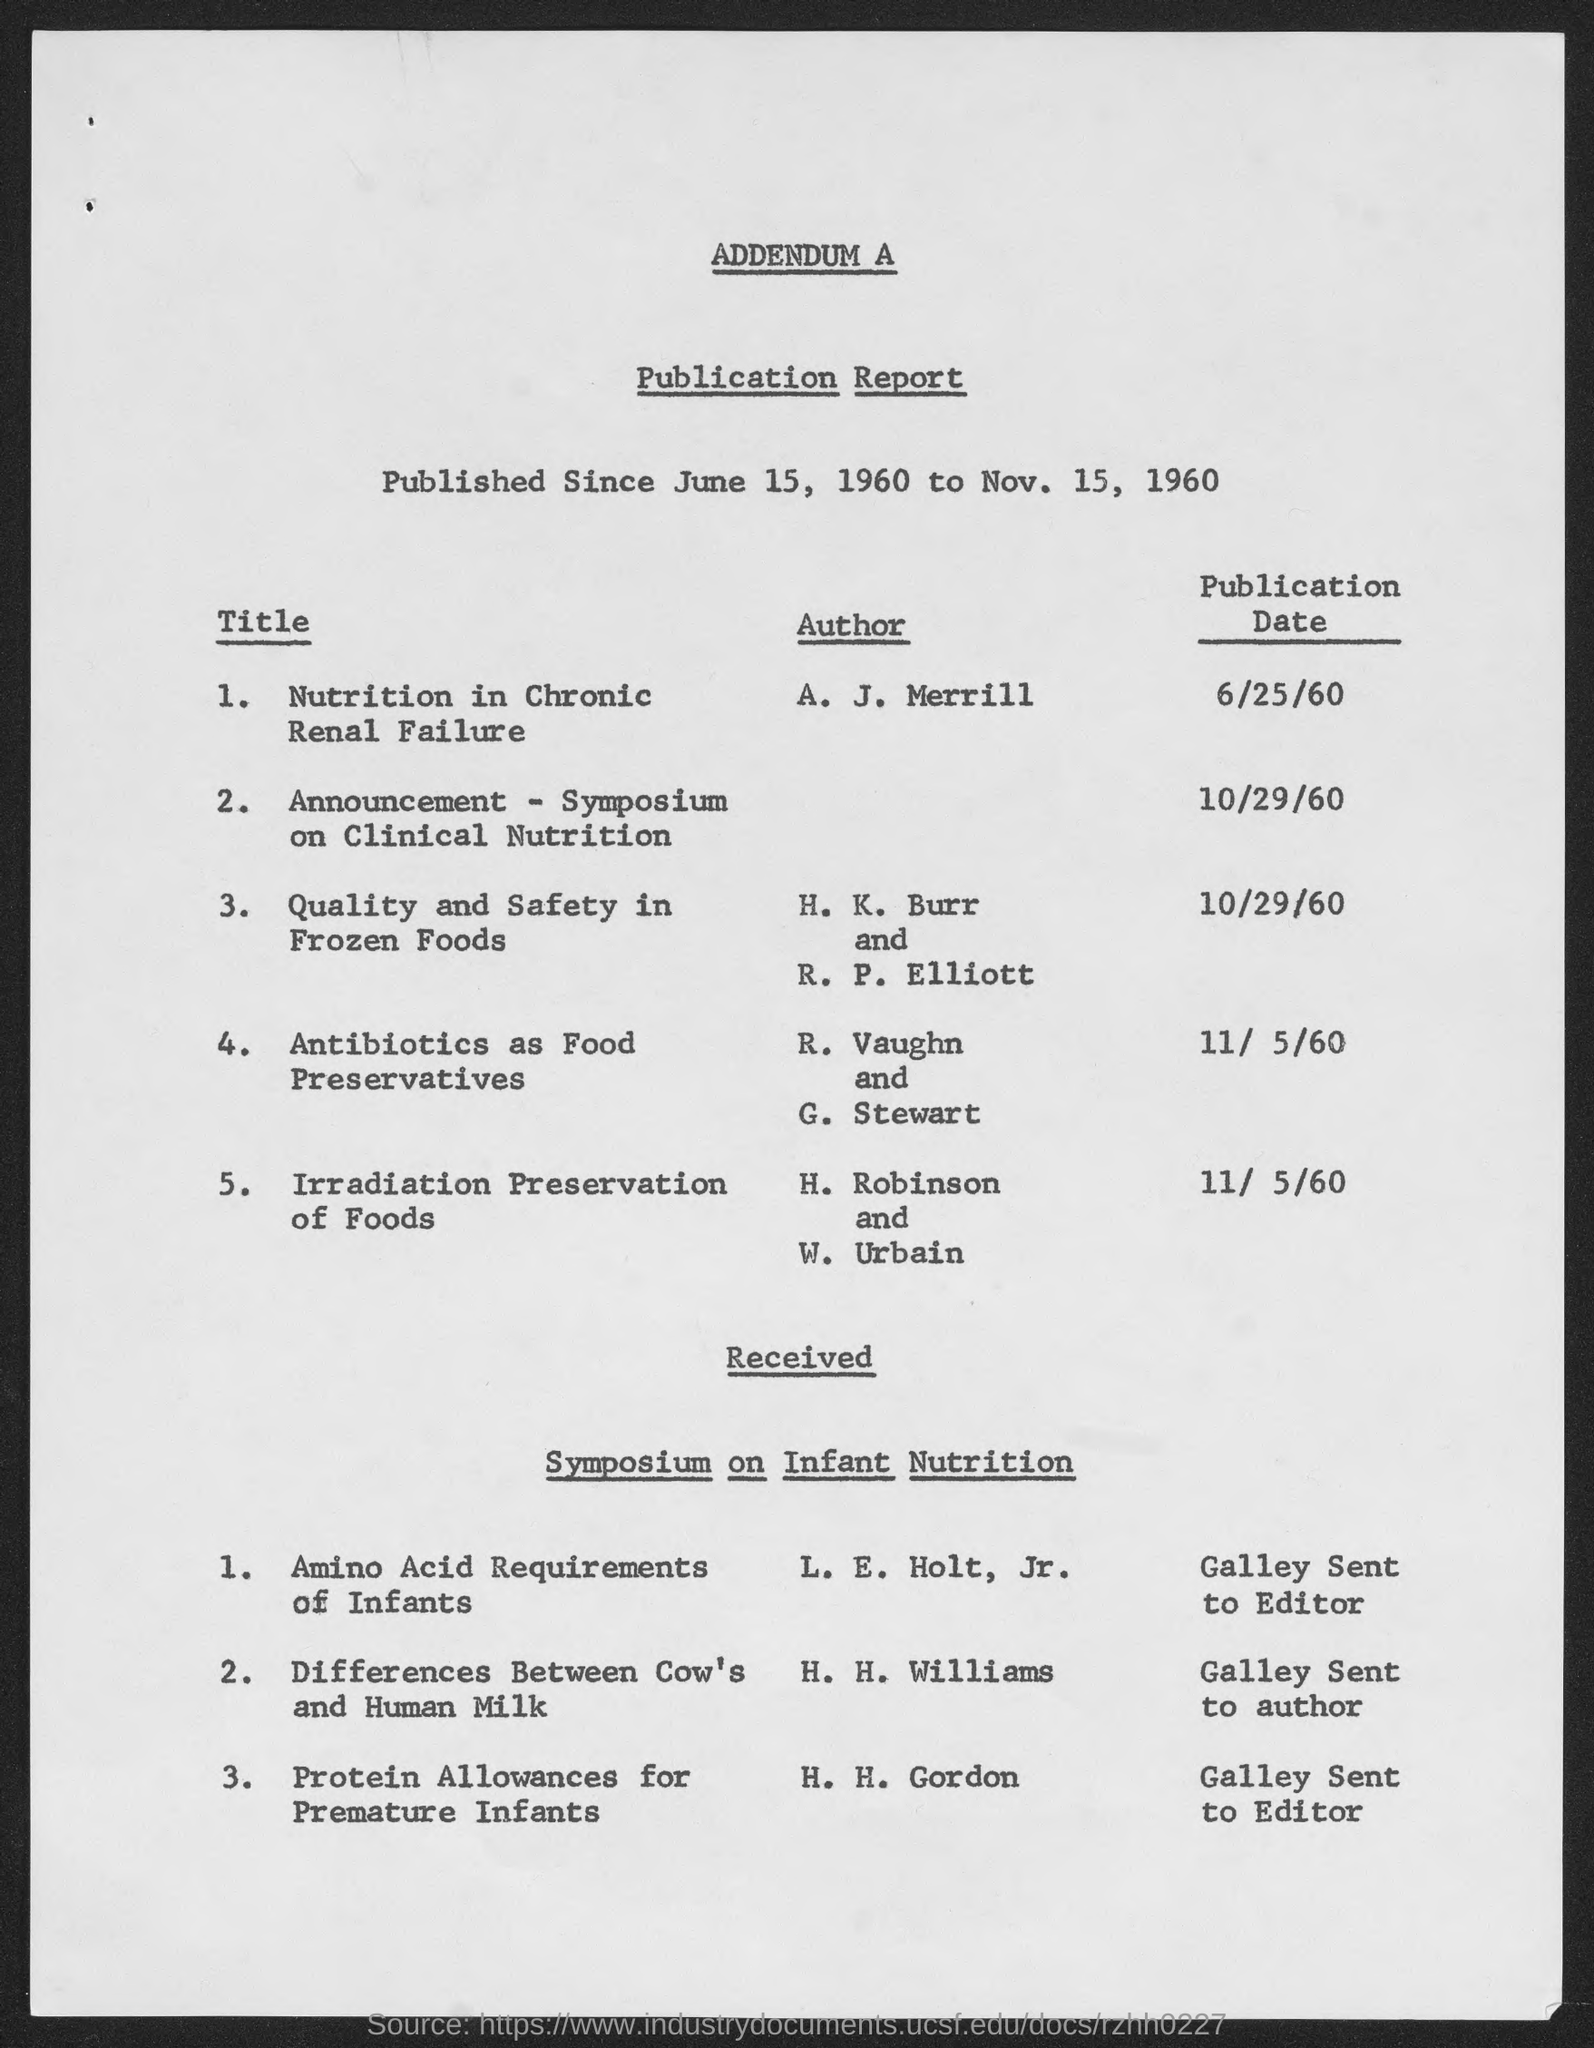Who is the author of "Nutrition in Chronic Renal Failure"?
Offer a terse response. A. J. Merrill. When was "quality and safety in frozen foods" published?
Keep it short and to the point. 10/29/60. 